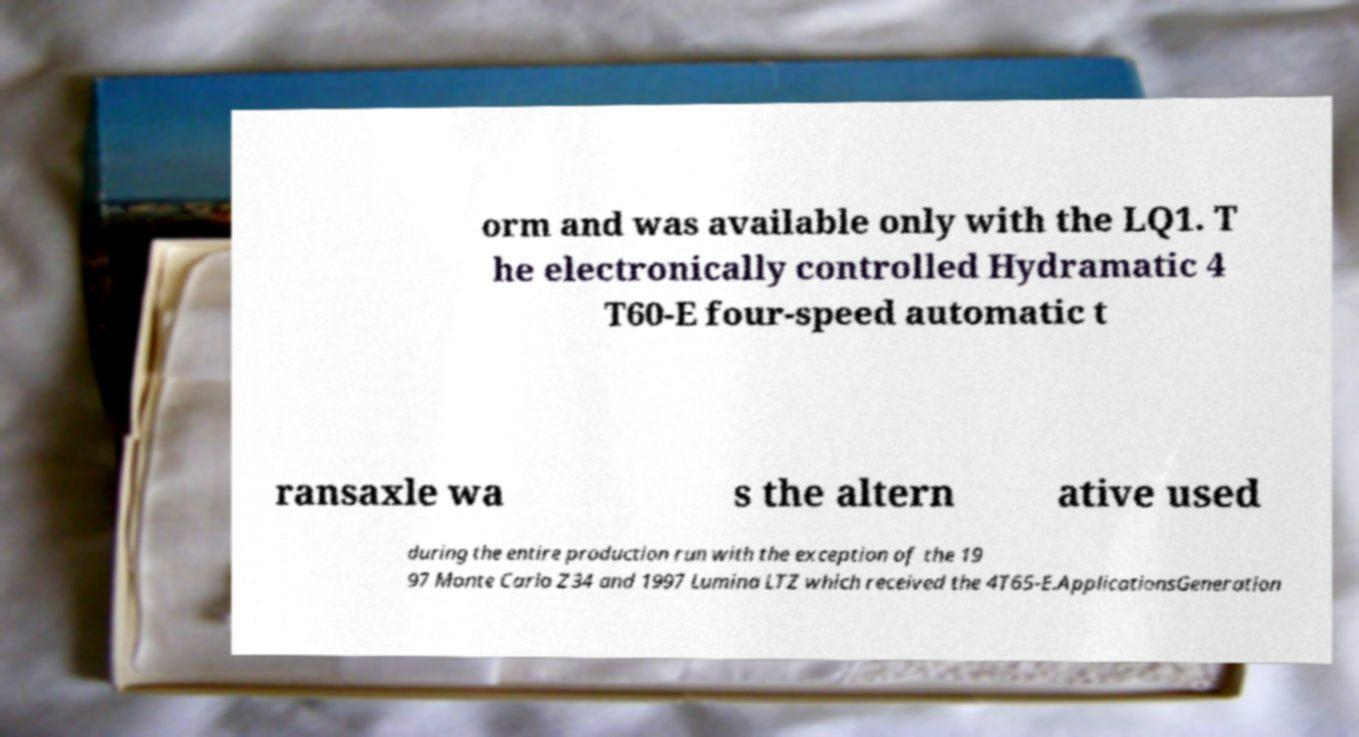Please identify and transcribe the text found in this image. orm and was available only with the LQ1. T he electronically controlled Hydramatic 4 T60-E four-speed automatic t ransaxle wa s the altern ative used during the entire production run with the exception of the 19 97 Monte Carlo Z34 and 1997 Lumina LTZ which received the 4T65-E.ApplicationsGeneration 